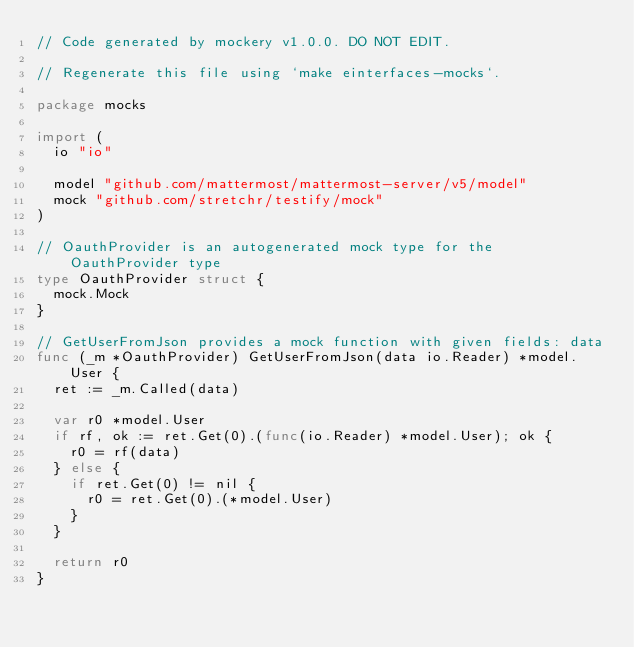<code> <loc_0><loc_0><loc_500><loc_500><_Go_>// Code generated by mockery v1.0.0. DO NOT EDIT.

// Regenerate this file using `make einterfaces-mocks`.

package mocks

import (
	io "io"

	model "github.com/mattermost/mattermost-server/v5/model"
	mock "github.com/stretchr/testify/mock"
)

// OauthProvider is an autogenerated mock type for the OauthProvider type
type OauthProvider struct {
	mock.Mock
}

// GetUserFromJson provides a mock function with given fields: data
func (_m *OauthProvider) GetUserFromJson(data io.Reader) *model.User {
	ret := _m.Called(data)

	var r0 *model.User
	if rf, ok := ret.Get(0).(func(io.Reader) *model.User); ok {
		r0 = rf(data)
	} else {
		if ret.Get(0) != nil {
			r0 = ret.Get(0).(*model.User)
		}
	}

	return r0
}
</code> 